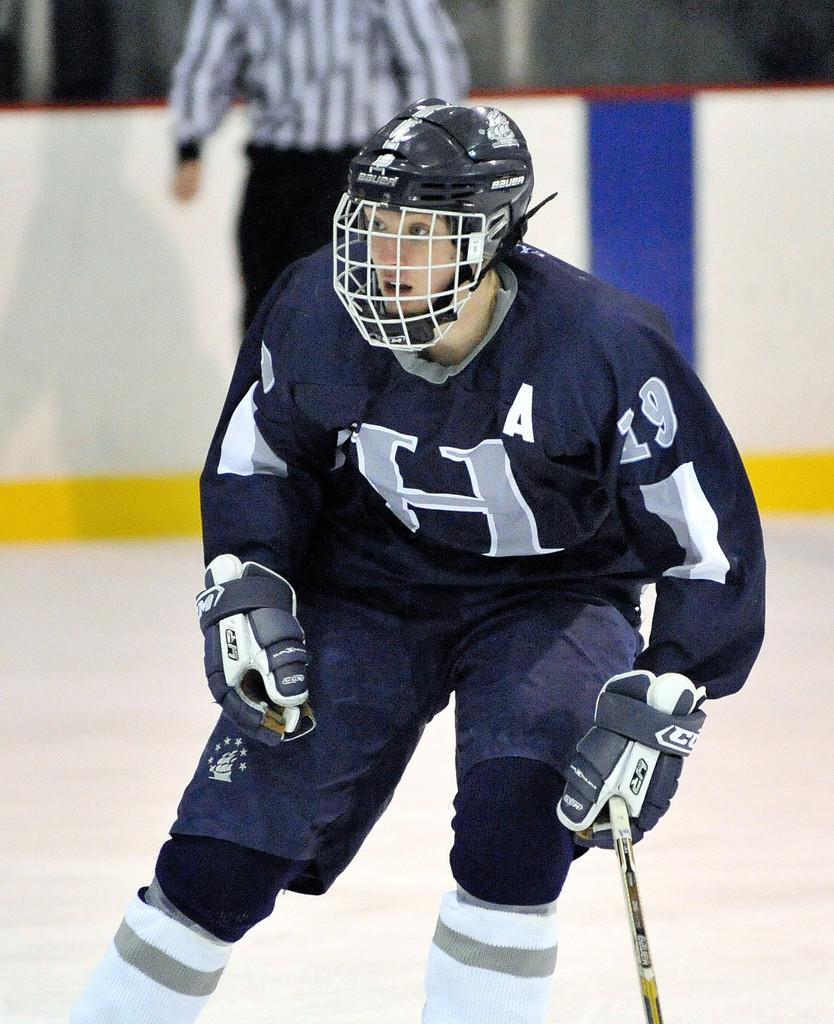What is the person in the image doing? The person is holding a hockey stick. What protective gear is the person wearing? The person is wearing a helmet. What can be seen in the background of the image? There is a wall in the background of the image. Can you describe the other person visible in the background? There is another person visible in the background, but only partially. What organization does the sail serve in the image? There is no sail present in the image, so it cannot serve any organization. 